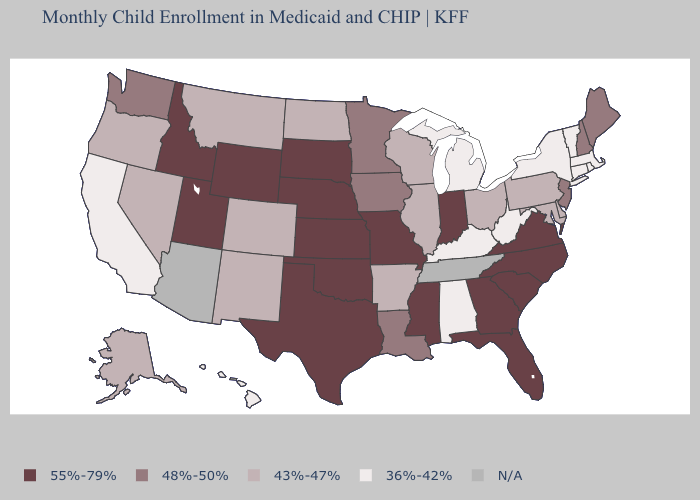Which states have the lowest value in the MidWest?
Write a very short answer. Michigan. Does Massachusetts have the highest value in the Northeast?
Write a very short answer. No. What is the value of South Dakota?
Quick response, please. 55%-79%. Which states hav the highest value in the South?
Be succinct. Florida, Georgia, Mississippi, North Carolina, Oklahoma, South Carolina, Texas, Virginia. Does the first symbol in the legend represent the smallest category?
Keep it brief. No. What is the value of Florida?
Be succinct. 55%-79%. What is the value of Michigan?
Answer briefly. 36%-42%. Among the states that border New Mexico , does Colorado have the highest value?
Answer briefly. No. Among the states that border Kansas , does Missouri have the highest value?
Keep it brief. Yes. Which states hav the highest value in the South?
Quick response, please. Florida, Georgia, Mississippi, North Carolina, Oklahoma, South Carolina, Texas, Virginia. What is the highest value in states that border Connecticut?
Concise answer only. 36%-42%. Does the first symbol in the legend represent the smallest category?
Quick response, please. No. What is the value of West Virginia?
Short answer required. 36%-42%. Name the states that have a value in the range 55%-79%?
Be succinct. Florida, Georgia, Idaho, Indiana, Kansas, Mississippi, Missouri, Nebraska, North Carolina, Oklahoma, South Carolina, South Dakota, Texas, Utah, Virginia, Wyoming. 